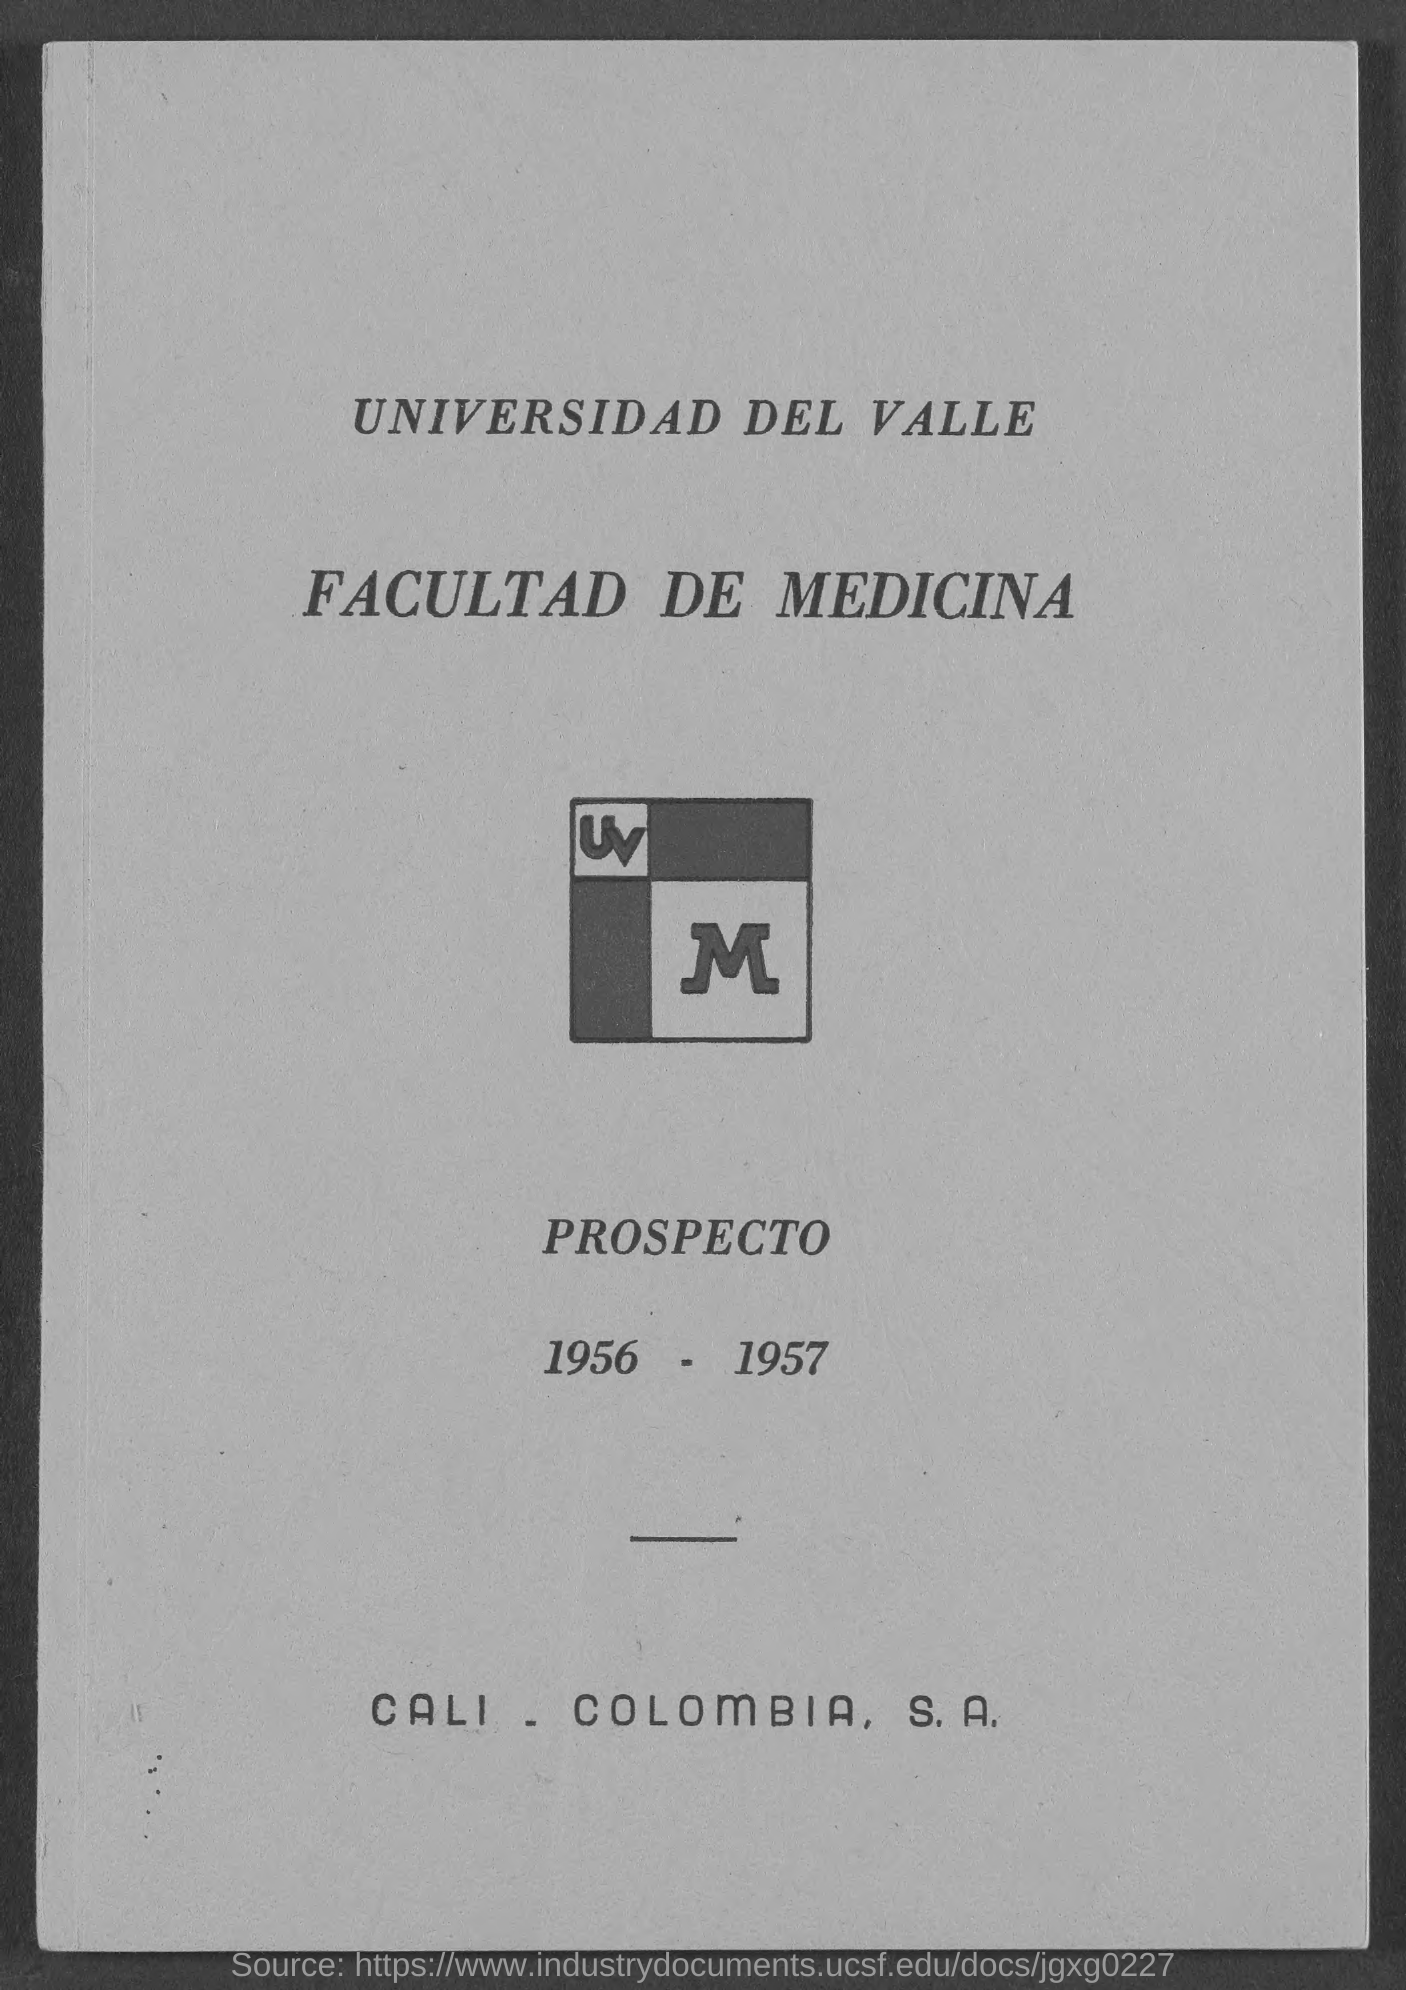What is the duration of the year mentioned here?
Offer a terse response. 1956 - 1957. 